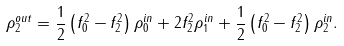Convert formula to latex. <formula><loc_0><loc_0><loc_500><loc_500>\rho _ { 2 } ^ { o u t } = \frac { 1 } { 2 } \left ( { f _ { 0 } ^ { 2 } - f _ { 2 } ^ { 2 } } \right ) \rho _ { 0 } ^ { i n } + 2 f _ { 2 } ^ { 2 } \rho _ { 1 } ^ { i n } + \frac { 1 } { 2 } \left ( { f _ { 0 } ^ { 2 } - f _ { 2 } ^ { 2 } } \right ) \rho _ { 2 } ^ { i n } .</formula> 